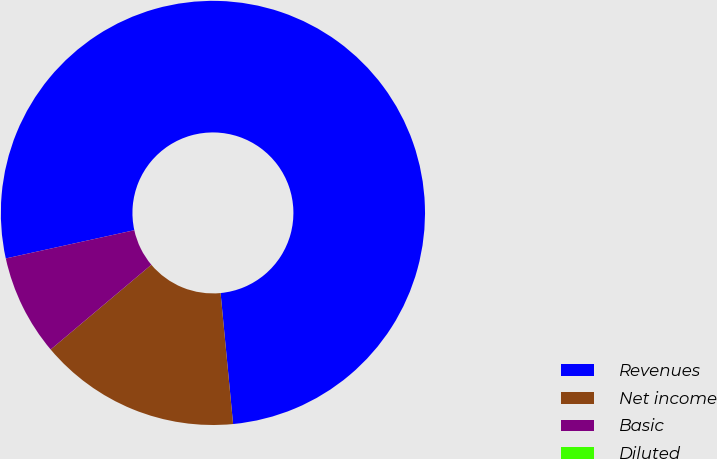Convert chart to OTSL. <chart><loc_0><loc_0><loc_500><loc_500><pie_chart><fcel>Revenues<fcel>Net income<fcel>Basic<fcel>Diluted<nl><fcel>76.92%<fcel>15.38%<fcel>7.69%<fcel>0.0%<nl></chart> 